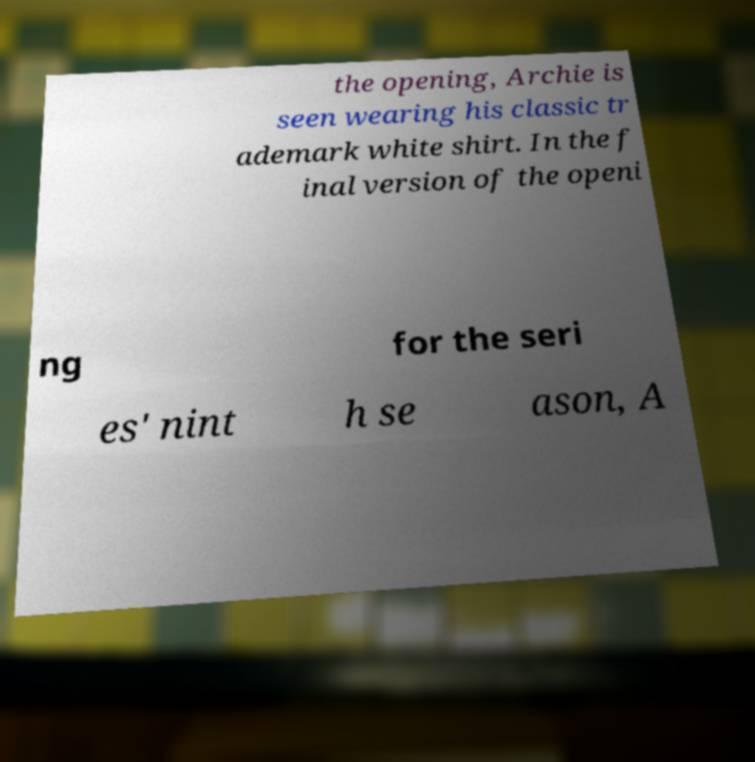Please read and relay the text visible in this image. What does it say? the opening, Archie is seen wearing his classic tr ademark white shirt. In the f inal version of the openi ng for the seri es' nint h se ason, A 